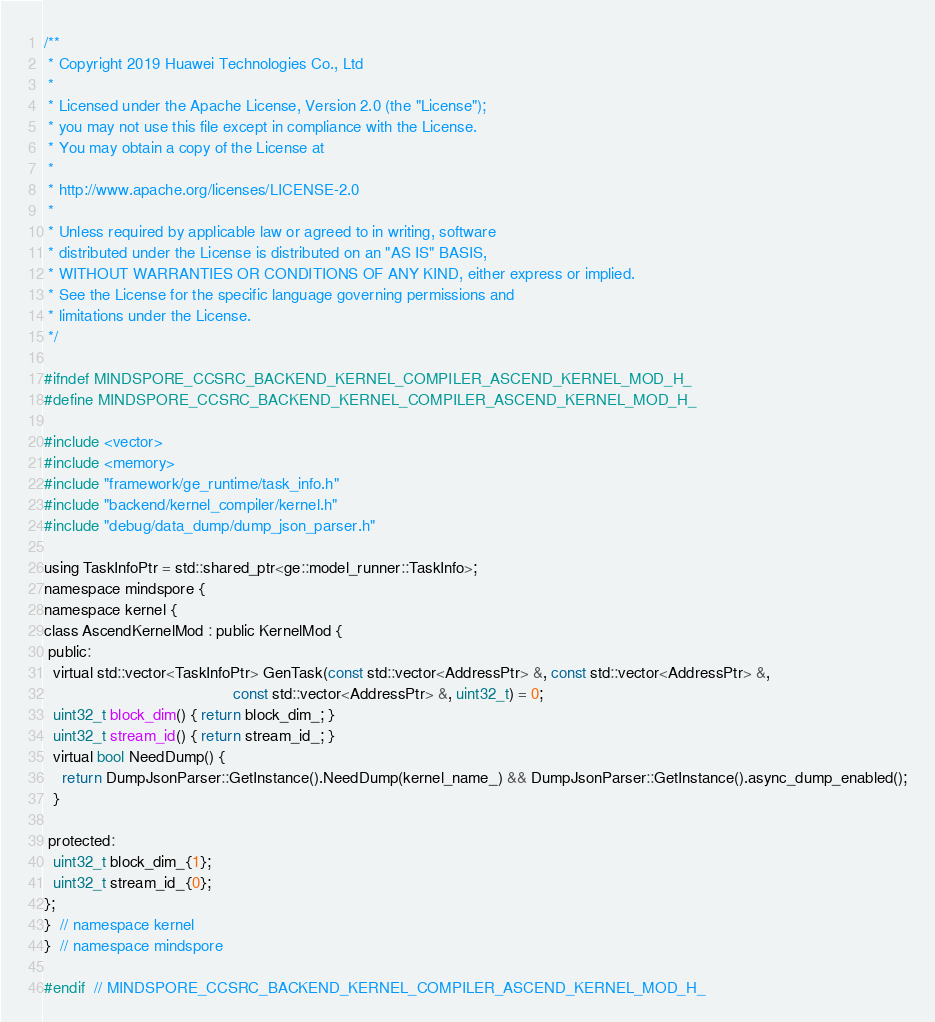Convert code to text. <code><loc_0><loc_0><loc_500><loc_500><_C_>/**
 * Copyright 2019 Huawei Technologies Co., Ltd
 *
 * Licensed under the Apache License, Version 2.0 (the "License");
 * you may not use this file except in compliance with the License.
 * You may obtain a copy of the License at
 *
 * http://www.apache.org/licenses/LICENSE-2.0
 *
 * Unless required by applicable law or agreed to in writing, software
 * distributed under the License is distributed on an "AS IS" BASIS,
 * WITHOUT WARRANTIES OR CONDITIONS OF ANY KIND, either express or implied.
 * See the License for the specific language governing permissions and
 * limitations under the License.
 */

#ifndef MINDSPORE_CCSRC_BACKEND_KERNEL_COMPILER_ASCEND_KERNEL_MOD_H_
#define MINDSPORE_CCSRC_BACKEND_KERNEL_COMPILER_ASCEND_KERNEL_MOD_H_

#include <vector>
#include <memory>
#include "framework/ge_runtime/task_info.h"
#include "backend/kernel_compiler/kernel.h"
#include "debug/data_dump/dump_json_parser.h"

using TaskInfoPtr = std::shared_ptr<ge::model_runner::TaskInfo>;
namespace mindspore {
namespace kernel {
class AscendKernelMod : public KernelMod {
 public:
  virtual std::vector<TaskInfoPtr> GenTask(const std::vector<AddressPtr> &, const std::vector<AddressPtr> &,
                                           const std::vector<AddressPtr> &, uint32_t) = 0;
  uint32_t block_dim() { return block_dim_; }
  uint32_t stream_id() { return stream_id_; }
  virtual bool NeedDump() {
    return DumpJsonParser::GetInstance().NeedDump(kernel_name_) && DumpJsonParser::GetInstance().async_dump_enabled();
  }

 protected:
  uint32_t block_dim_{1};
  uint32_t stream_id_{0};
};
}  // namespace kernel
}  // namespace mindspore

#endif  // MINDSPORE_CCSRC_BACKEND_KERNEL_COMPILER_ASCEND_KERNEL_MOD_H_
</code> 